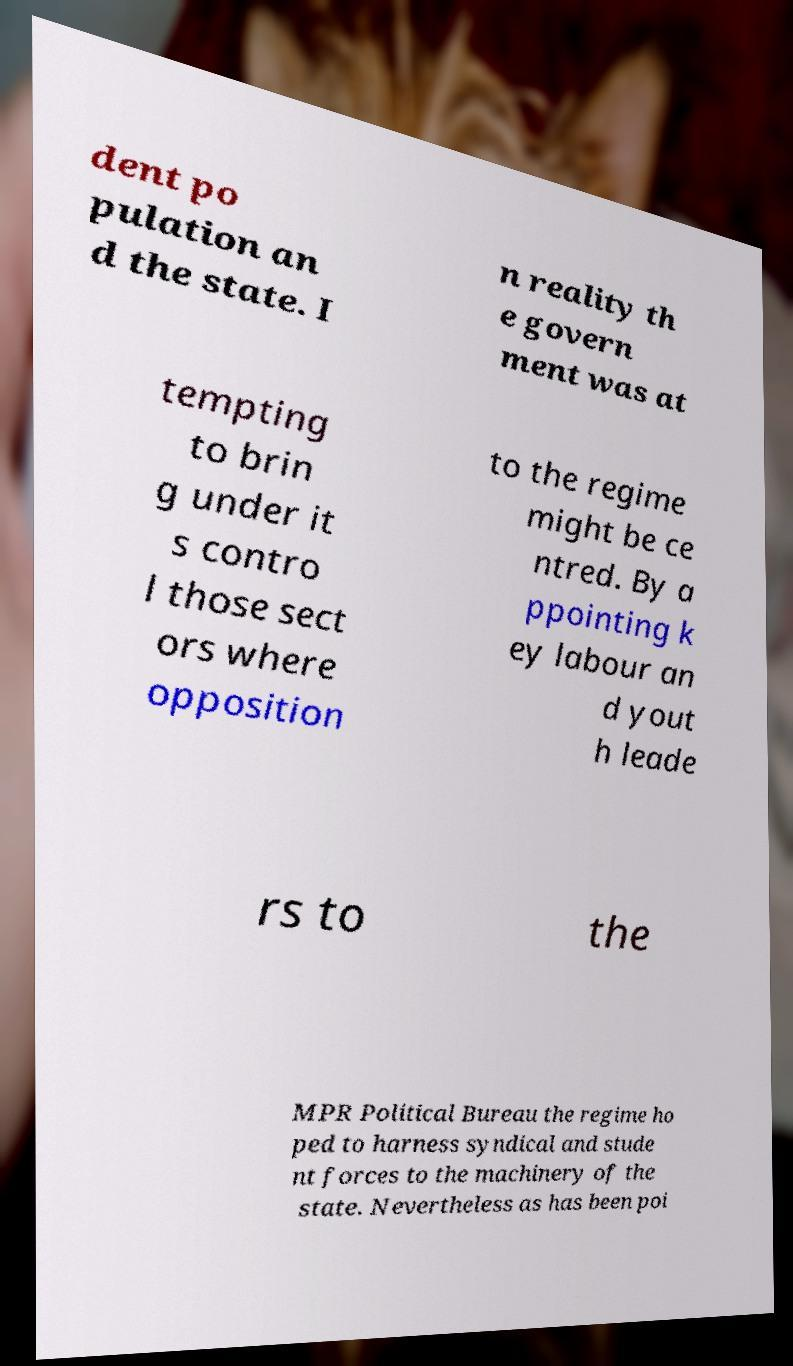There's text embedded in this image that I need extracted. Can you transcribe it verbatim? dent po pulation an d the state. I n reality th e govern ment was at tempting to brin g under it s contro l those sect ors where opposition to the regime might be ce ntred. By a ppointing k ey labour an d yout h leade rs to the MPR Political Bureau the regime ho ped to harness syndical and stude nt forces to the machinery of the state. Nevertheless as has been poi 